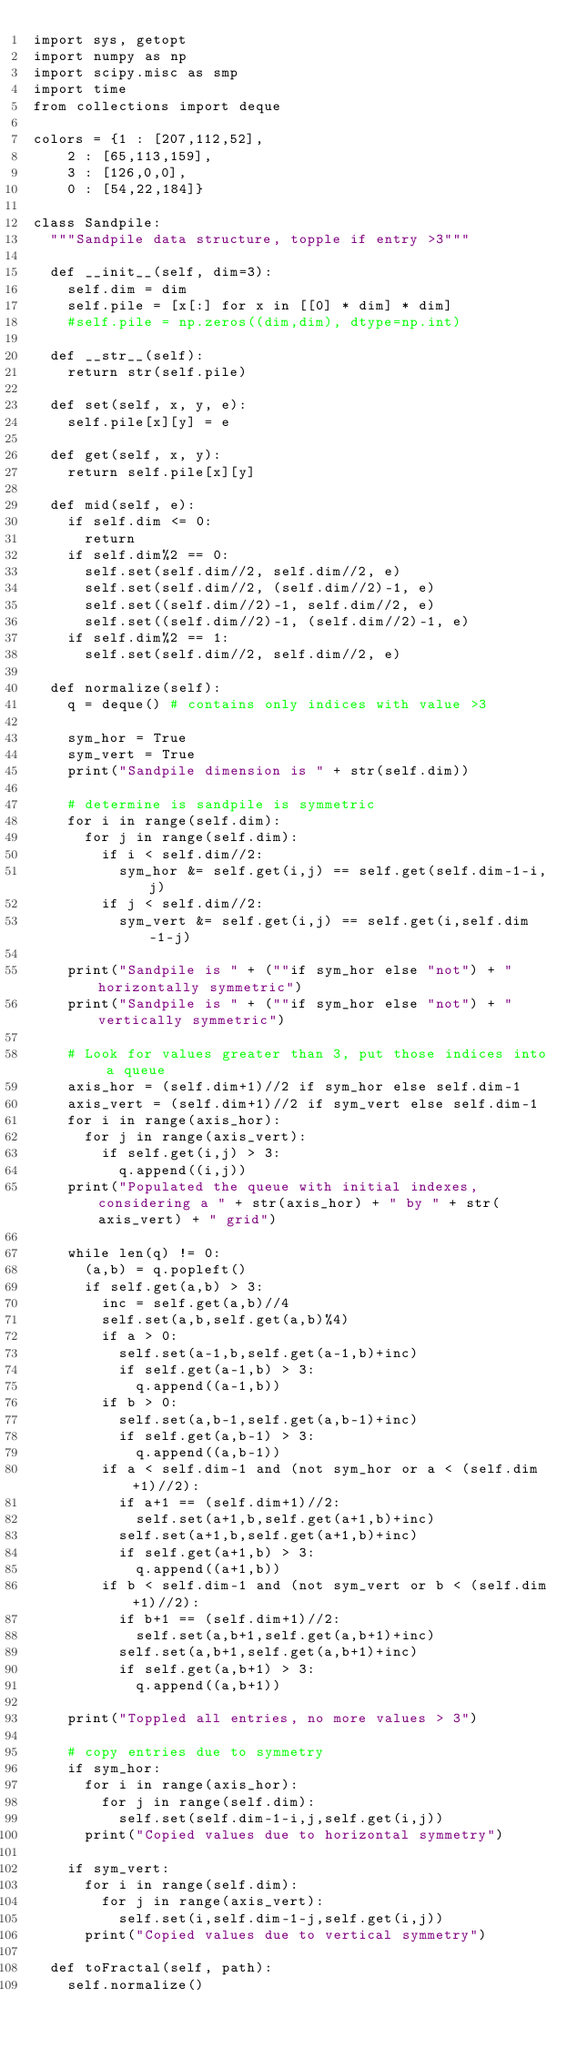Convert code to text. <code><loc_0><loc_0><loc_500><loc_500><_Python_>import sys, getopt
import numpy as np
import scipy.misc as smp
import time
from collections import deque

colors = {1 : [207,112,52],
		2 : [65,113,159],
		3 : [126,0,0],
		0 : [54,22,184]}

class Sandpile:
	"""Sandpile data structure, topple if entry >3"""

	def __init__(self, dim=3):
		self.dim = dim
		self.pile = [x[:] for x in [[0] * dim] * dim]
		#self.pile = np.zeros((dim,dim), dtype=np.int)

	def __str__(self):
		return str(self.pile)

	def set(self, x, y, e):
		self.pile[x][y] = e

	def get(self, x, y):
		return self.pile[x][y]

	def mid(self, e):
		if self.dim <= 0:
			return
		if self.dim%2 == 0:
			self.set(self.dim//2, self.dim//2, e)
			self.set(self.dim//2, (self.dim//2)-1, e)
			self.set((self.dim//2)-1, self.dim//2, e)
			self.set((self.dim//2)-1, (self.dim//2)-1, e)
		if self.dim%2 == 1:
			self.set(self.dim//2, self.dim//2, e)

	def normalize(self):
		q = deque() # contains only indices with value >3

		sym_hor = True
		sym_vert = True
		print("Sandpile dimension is " + str(self.dim))

		# determine is sandpile is symmetric
		for i in range(self.dim):
			for j in range(self.dim):
				if i < self.dim//2:
					sym_hor &= self.get(i,j) == self.get(self.dim-1-i,j)
				if j < self.dim//2:
					sym_vert &= self.get(i,j) == self.get(i,self.dim-1-j)

		print("Sandpile is " + (""if sym_hor else "not") + "horizontally symmetric")
		print("Sandpile is " + (""if sym_hor else "not") + "vertically symmetric")

		# Look for values greater than 3, put those indices into a queue
		axis_hor = (self.dim+1)//2 if sym_hor else self.dim-1
		axis_vert = (self.dim+1)//2 if sym_vert else self.dim-1
		for i in range(axis_hor):
			for j in range(axis_vert):
				if self.get(i,j) > 3:
					q.append((i,j))
		print("Populated the queue with initial indexes, considering a " + str(axis_hor) + " by " + str(axis_vert) + " grid")

		while len(q) != 0:
			(a,b) = q.popleft()
			if self.get(a,b) > 3:	
				inc = self.get(a,b)//4
				self.set(a,b,self.get(a,b)%4)
				if a > 0:
					self.set(a-1,b,self.get(a-1,b)+inc)
					if self.get(a-1,b) > 3:
						q.append((a-1,b))
				if b > 0:
					self.set(a,b-1,self.get(a,b-1)+inc)
					if self.get(a,b-1) > 3:
						q.append((a,b-1))
				if a < self.dim-1 and (not sym_hor or a < (self.dim+1)//2):
					if a+1 == (self.dim+1)//2:
						self.set(a+1,b,self.get(a+1,b)+inc)
					self.set(a+1,b,self.get(a+1,b)+inc)
					if self.get(a+1,b) > 3:
						q.append((a+1,b))
				if b < self.dim-1 and (not sym_vert or b < (self.dim+1)//2):
					if b+1 == (self.dim+1)//2:
						self.set(a,b+1,self.get(a,b+1)+inc)	
					self.set(a,b+1,self.get(a,b+1)+inc)
					if self.get(a,b+1) > 3:
						q.append((a,b+1))

		print("Toppled all entries, no more values > 3")

		# copy entries due to symmetry
		if sym_hor:
			for i in range(axis_hor):
				for j in range(self.dim):
					self.set(self.dim-1-i,j,self.get(i,j))
			print("Copied values due to horizontal symmetry")

		if sym_vert: 
			for i in range(self.dim):
				for j in range(axis_vert):
					self.set(i,self.dim-1-j,self.get(i,j))
			print("Copied values due to vertical symmetry")
		
	def toFractal(self, path):
		self.normalize()</code> 